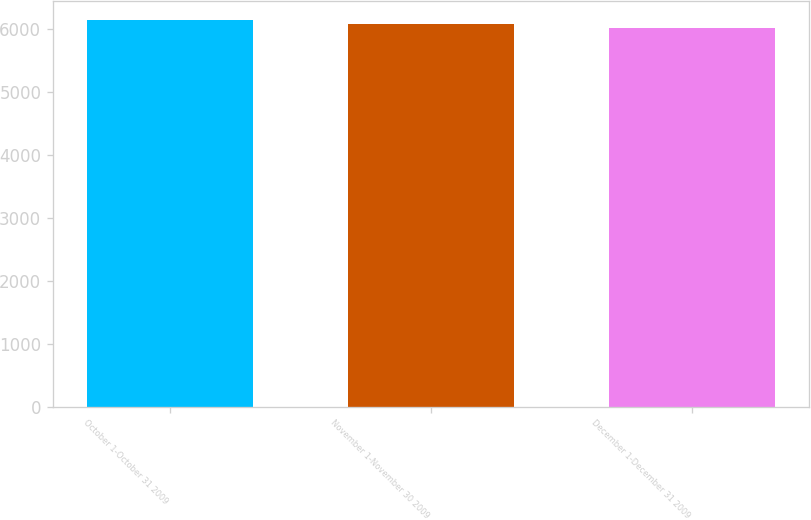<chart> <loc_0><loc_0><loc_500><loc_500><bar_chart><fcel>October 1-October 31 2009<fcel>November 1-November 30 2009<fcel>December 1-December 31 2009<nl><fcel>6136<fcel>6080<fcel>6003<nl></chart> 